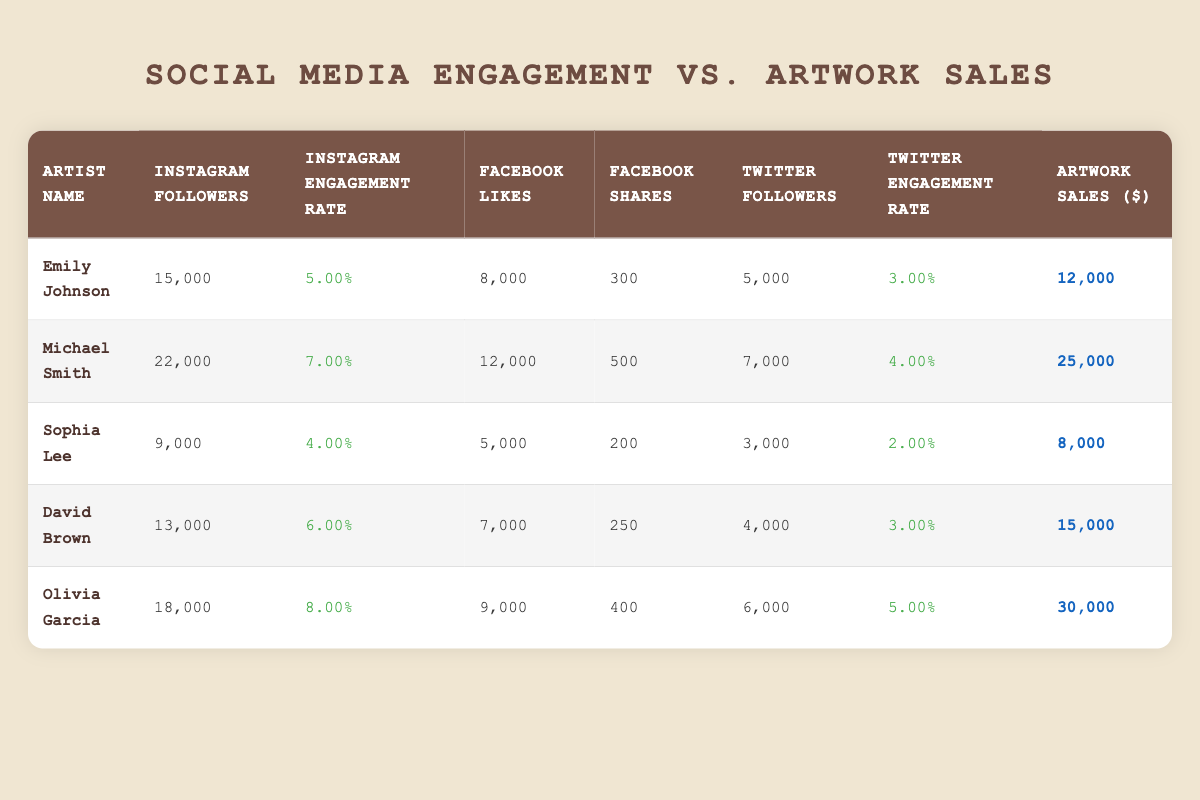What is the highest number of Instagram followers among the artists listed? The table indicates that Michael Smith has 22,000 Instagram followers, which is the highest figure compared to the others.
Answer: 22,000 Which artist has the highest artwork sales? According to the table, Olivia Garcia has the highest artwork sales at $30,000.
Answer: $30,000 Is there an artist with more than 15,000 Facebook likes? Looking at the table, both Michael Smith and Olivia Garcia have more than 15,000 Facebook likes. Therefore, the answer is yes.
Answer: Yes What is the average Instagram engagement rate of the artists? To find the average, sum the engagement rates: (0.05 + 0.07 + 0.04 + 0.06 + 0.08) = 0.30. Divide by the number of artists (5): 0.30/5 = 0.06.
Answer: 0.06 Does a higher number of Instagram followers correlate with higher artwork sales among the artists listed? Analyzing the data: Emily Johnson has 15,000 followers and $12,000 in sales; Michael Smith with 22,000 followers has $25,000 in sales; Sophia Lee has 9,000 followers and $8,000 in sales; David Brown with 13,000 followers has $15,000 in sales; Olivia Garcia with 18,000 followers has $30,000 in sales. Overall, as followers increase, artwork sales tend to rise. This suggests a positive correlation, though not definitive.
Answer: Yes What is the total number of Facebook shares for all the artists combined? The total can be calculated by adding the shares: 300 + 500 + 200 + 250 + 400 = 1,650.
Answer: 1,650 